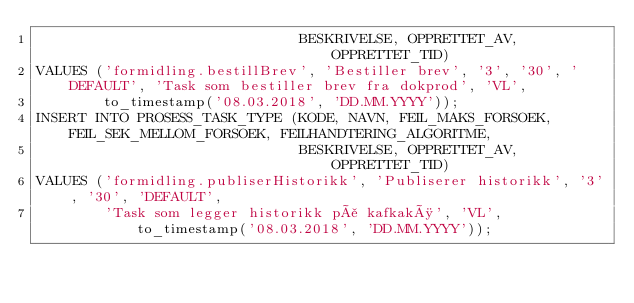<code> <loc_0><loc_0><loc_500><loc_500><_SQL_>                               BESKRIVELSE, OPPRETTET_AV, OPPRETTET_TID)
VALUES ('formidling.bestillBrev', 'Bestiller brev', '3', '30', 'DEFAULT', 'Task som bestiller brev fra dokprod', 'VL',
        to_timestamp('08.03.2018', 'DD.MM.YYYY'));
INSERT INTO PROSESS_TASK_TYPE (KODE, NAVN, FEIL_MAKS_FORSOEK, FEIL_SEK_MELLOM_FORSOEK, FEILHANDTERING_ALGORITME,
                               BESKRIVELSE, OPPRETTET_AV, OPPRETTET_TID)
VALUES ('formidling.publiserHistorikk', 'Publiserer historikk', '3', '30', 'DEFAULT',
        'Task som legger historikk på kafkakø', 'VL', to_timestamp('08.03.2018', 'DD.MM.YYYY'));</code> 